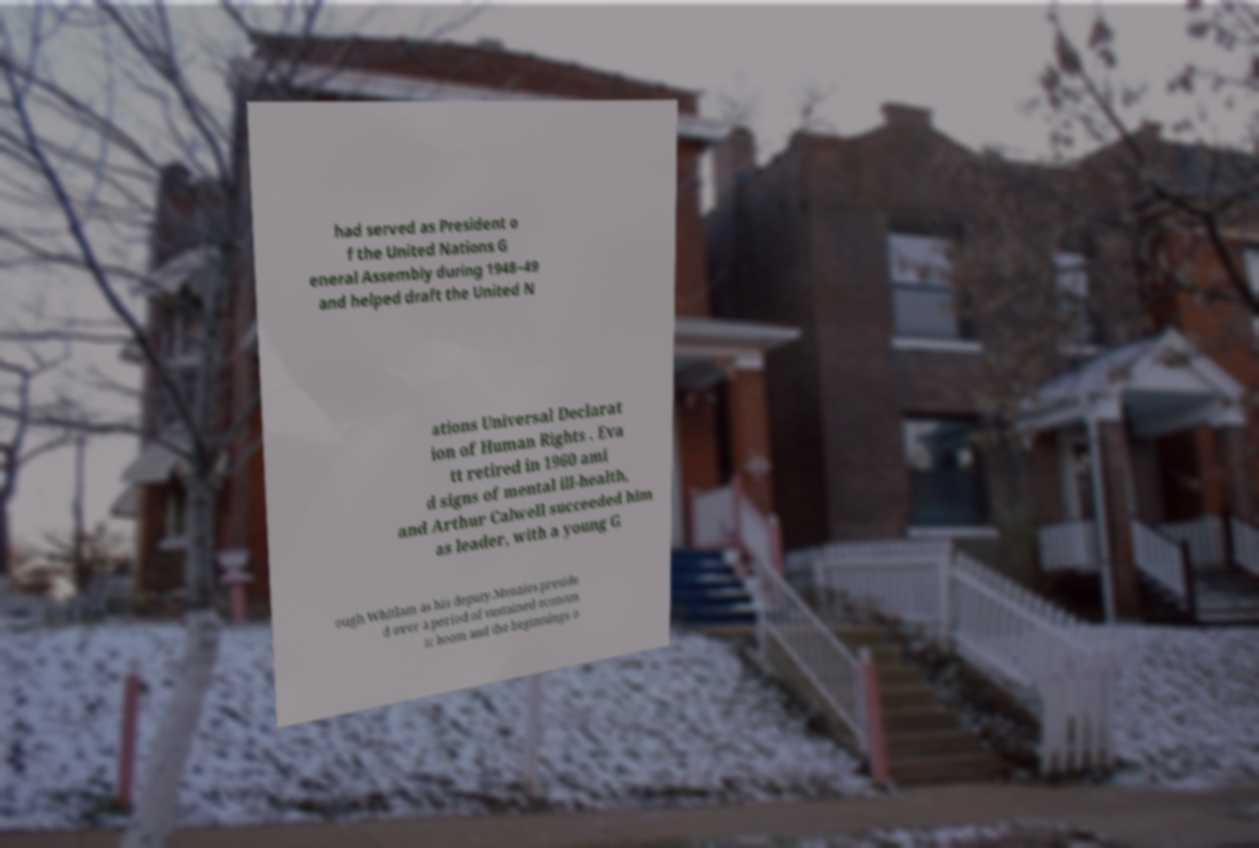What messages or text are displayed in this image? I need them in a readable, typed format. had served as President o f the United Nations G eneral Assembly during 1948–49 and helped draft the United N ations Universal Declarat ion of Human Rights . Eva tt retired in 1960 ami d signs of mental ill-health, and Arthur Calwell succeeded him as leader, with a young G ough Whitlam as his deputy.Menzies preside d over a period of sustained econom ic boom and the beginnings o 